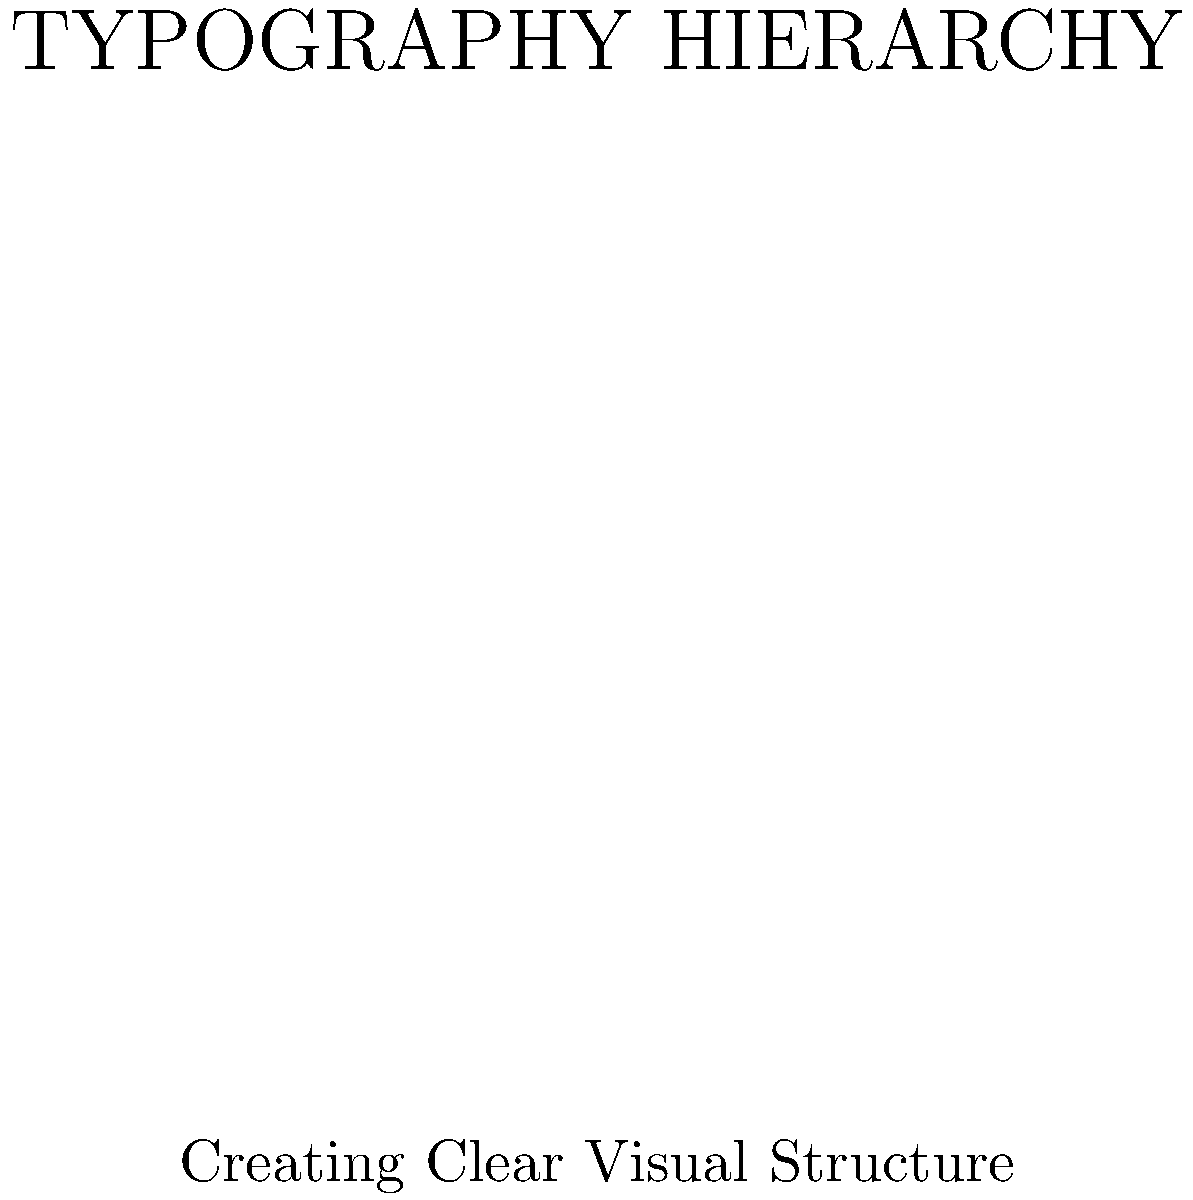In the given layout, which typographic element serves as the primary focal point and establishes the main hierarchy? To determine the primary focal point and main hierarchy in this typographic layout, we need to analyze the various elements:

1. The text "TYPOGRAPHY HIERARCHY" is positioned at the top of the layout.
2. It uses the largest font size compared to other elements.
3. It's separated from other elements by a horizontal line, giving it more emphasis.
4. The text is in all caps, which adds visual weight.
5. Its placement at the top naturally draws the eye first.

These factors combined make "TYPOGRAPHY HIERARCHY" the primary focal point and the element that establishes the main hierarchy in the layout. It's the first thing a viewer would likely notice and read, setting the tone for the rest of the content.

The other elements in the layout support this hierarchy:
- The subtitle provides additional context but is smaller and less prominent.
- The body text is even smaller and centered, clearly subordinate to the main title.
- The "LEARN MORE" text at the bottom, while slightly larger than the body text, is still secondary to the main title.

This arrangement creates a clear visual hierarchy that guides the viewer's eye from the most important information to the least important.
Answer: The main title "TYPOGRAPHY HIERARCHY" 